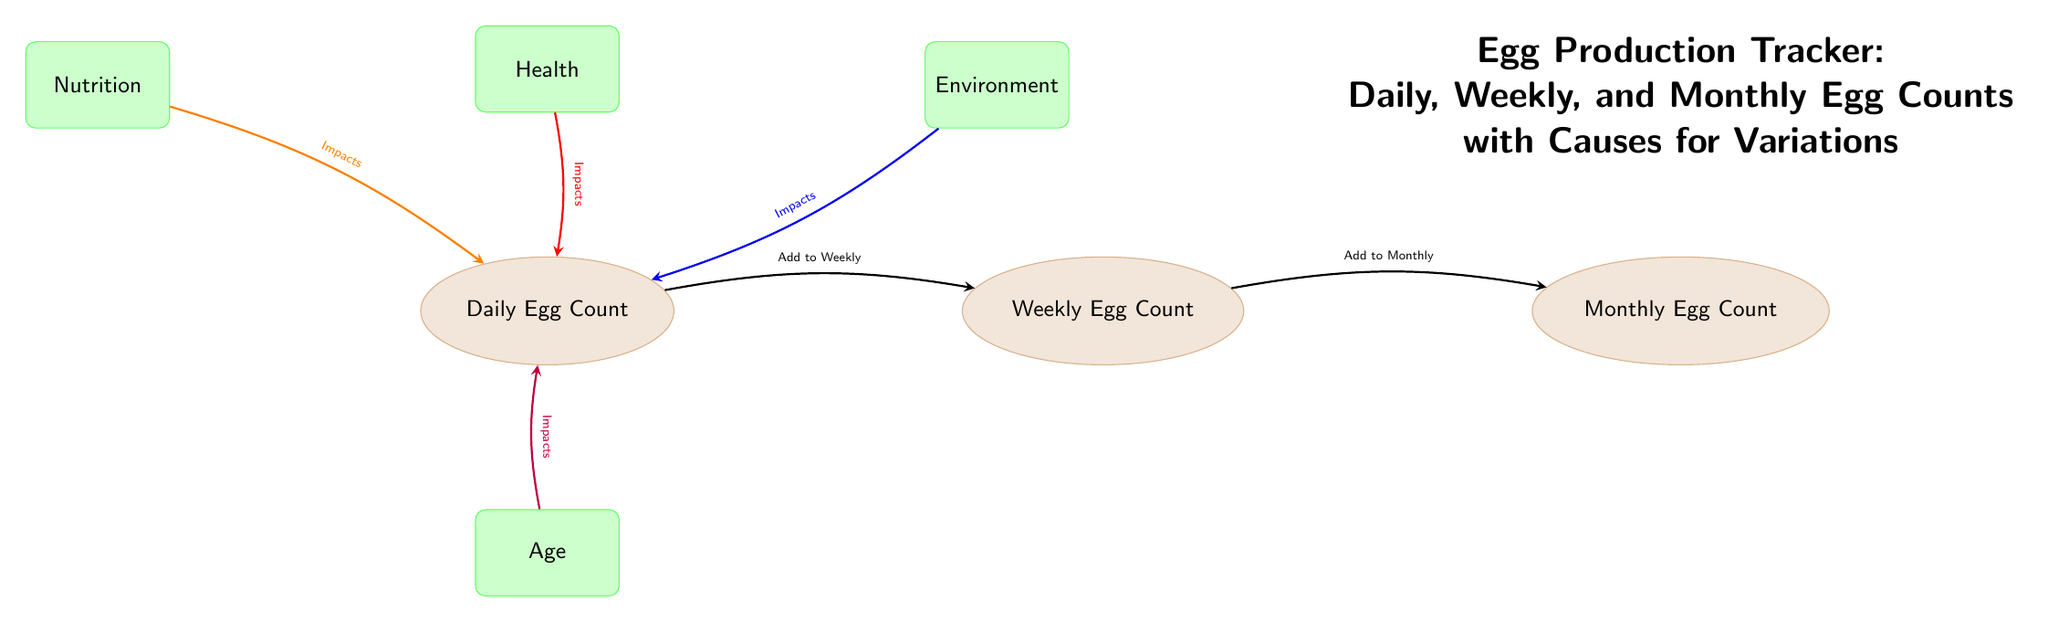What is the title of the diagram? The title is explicitly written at the top of the diagram, indicating what the diagram is about. By scanning the diagram, we see "Egg Production Tracker: Daily, Weekly, and Monthly Egg Counts with Causes for Variations" positioned prominently above the nodes.
Answer: Egg Production Tracker: Daily, Weekly, and Monthly Egg Counts with Causes for Variations How many egg count nodes are present? The diagram includes three egg count nodes: Daily Egg Count, Weekly Egg Count, and Monthly Egg Count. Counting these nodes gives us a total of three.
Answer: 3 Which factor impacts the daily egg count and is shown in red? The diagram shows Health as a factor that impacts the daily egg count, represented visually in red with a connecting arrow leading to the Daily Egg Count node.
Answer: Health What direction do the arrows between Daily, Weekly, and Monthly egg counts point? Examining the arrows, we see that they point from Daily to Weekly and from Weekly to Monthly. This indicates a flow of information or counting from the Daily Egg Count to the Weekly and subsequently to the Monthly Egg Count.
Answer: Right Which factor has the least visual prominence in terms of color? The Age factor is shown with a more subdued color compared to the other factors. While it's still a noticeable element, it lacks the vivid colors used for Nutrition, Health, and Environment, leading us to conclude it is visually less prominent.
Answer: Age What do the arrows indicate between Daily, Weekly, and Monthly counts? The arrows indicate the accumulation or summative process involved, where the Daily Egg Counts are added to the Weekly Count, which in turn is added to the Monthly Count, illustrating the tracking progression of egg counts over time.
Answer: Accumulation How many factors are shown that impact daily egg count? There are four factors indicated in the diagram that impact daily egg count: Nutrition, Health, Environment, and Age. Counting these gives a total of four impacting factors.
Answer: 4 Which color represents the Nutrition factor in the diagram? The Nutrition factor is represented in green, denoting its role in impacting the daily egg count, as indicated by the visual design choice of that color.
Answer: Green What type of diagram is this? The diagram is a flowchart-style representation of relationships, illustrating how egg counts are tracked over time along with the factors that influence daily production, characteristic of a Textbook Diagram.
Answer: Textbook Diagram 